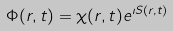Convert formula to latex. <formula><loc_0><loc_0><loc_500><loc_500>\Phi ( { r } , t ) = \chi ( { r } , t ) e ^ { \imath S ( { r } , t ) }</formula> 